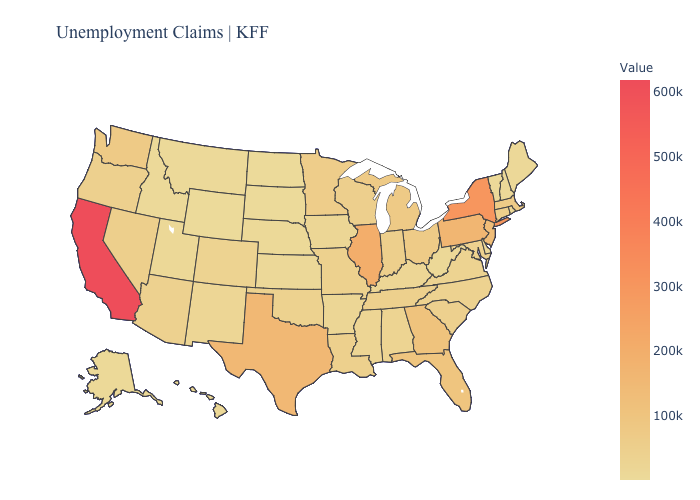Among the states that border Idaho , does Montana have the highest value?
Be succinct. No. Does Connecticut have a higher value than Illinois?
Answer briefly. No. Does New York have the highest value in the Northeast?
Be succinct. Yes. 